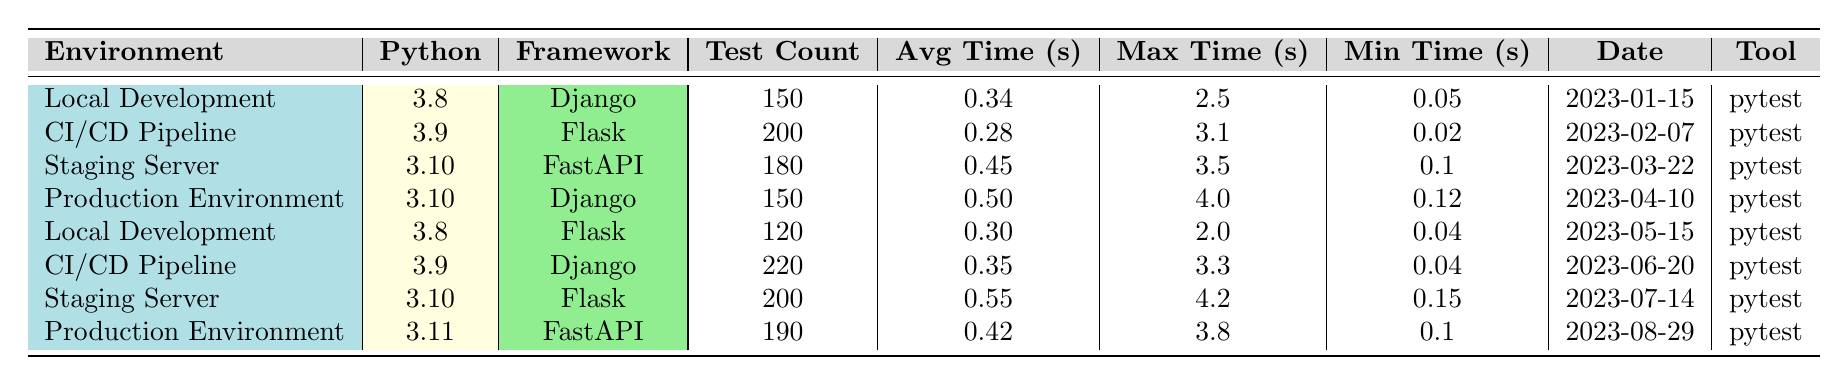What is the average execution time for the tests run in CI/CD Pipeline for Flask? The average execution time is given directly in the table under the Avg Time column for CI/CD Pipeline with Flask, which is 0.28 seconds.
Answer: 0.28 seconds What is the maximum execution time recorded for tests in the Production Environment using Django? The maximum execution time is provided in the table under the Max Time column for Production Environment with Django, which is 4.0 seconds.
Answer: 4.0 seconds Which environment had the lowest average execution time and what was it? To determine the lowest average execution time, we look at the Avg Time column across all environments. The lowest value is 0.28 seconds in the CI/CD Pipeline for Flask.
Answer: 0.28 seconds How many tests were executed in the Staging Server using Flask? The test count for the Staging Server with Flask is clearly stated in the table under the Test Count column, which is 200.
Answer: 200 What is the difference in average execution times between the Local Development for Django and the Production Environment for Django? The average execution time for Local Development with Django is 0.34 seconds, while for the Production Environment with Django it is 0.50 seconds. The difference is calculated as 0.50 - 0.34 = 0.16 seconds.
Answer: 0.16 seconds Did any environment have a minimum execution time of less than 0.1 seconds? We can check the Min Time column for all environments. The Local Development environment for Django had a minimum time of 0.05 seconds, which is less than 0.1 seconds.
Answer: Yes Which framework had the highest maximum execution time and what was that time? To find this, we look at the Max Time column. The highest maximum execution time recorded is 4.2 seconds for the Staging Server using Flask.
Answer: 4.2 seconds Is there a correlation between the Python version and average execution time? While we assess the data in the Avg Time column alongside different Python versions, there's no straightforward pattern indicating a direct correlation. For example, Python 3.8 had 0.34 and 0.30, whereas 3.10 had 0.45 and 0.55, indicating variation without a clear trend.
Answer: No Which environment had the largest test count and how many tests were executed? The largest test count is found under the Test Count column, specifically for the CI/CD Pipeline using Django, which had 220 tests executed.
Answer: 220 tests What was the average execution time for the Production Environment using FastAPI? The average execution time for the Production Environment with FastAPI is stated under the Avg Time column, which is 0.42 seconds.
Answer: 0.42 seconds How many tests were executed in total across all environments? To find the total number of tests, we sum the Test Count for each row: 150 + 200 + 180 + 150 + 120 + 220 + 200 + 190 = 1310.
Answer: 1310 tests 